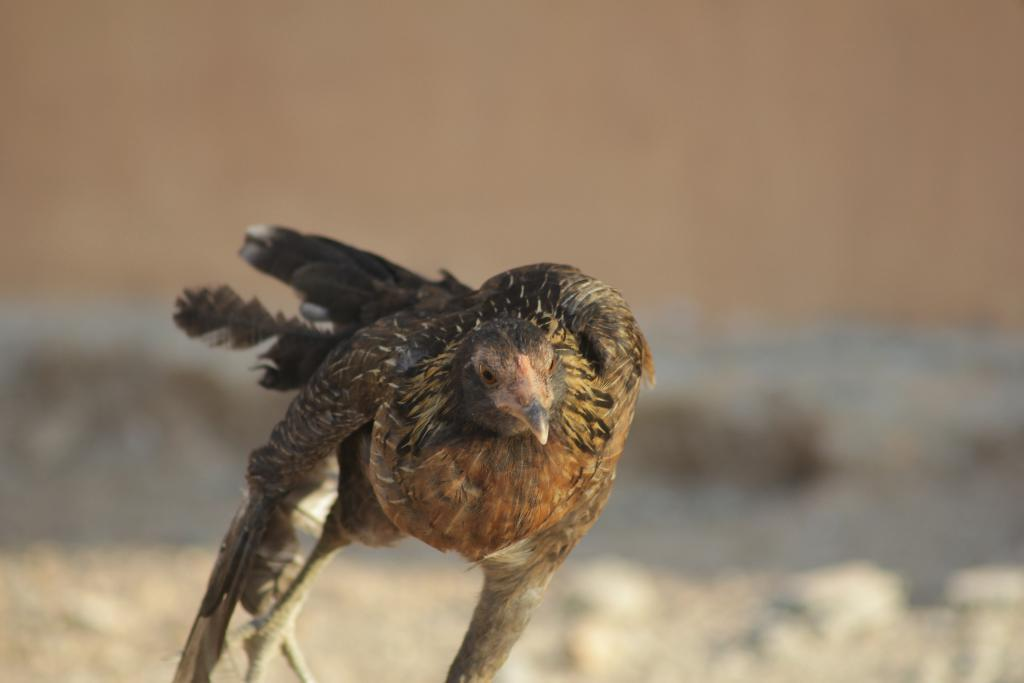What type of animal can be seen in the image? There is a bird in the image. What is the background of the image? There is a wall visible in the image. What type of farmer is taking care of the bird in the image? There is no farmer present in the image, and the bird is not being taken care of by anyone. 